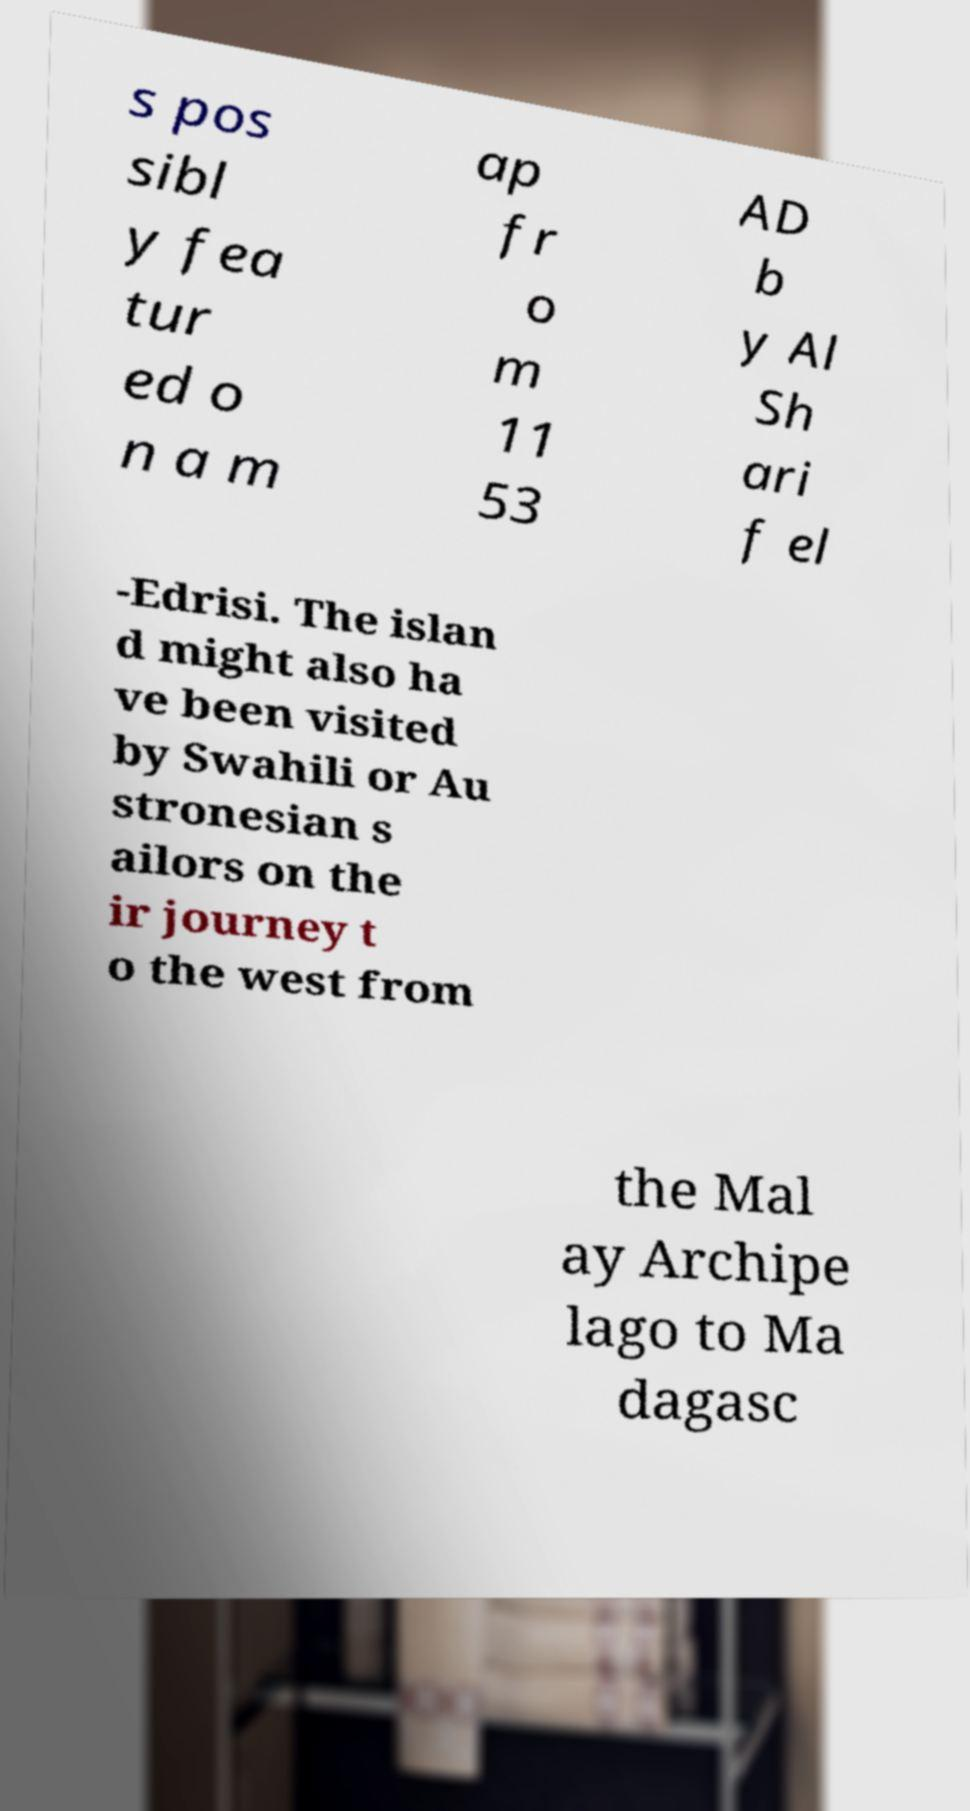Could you extract and type out the text from this image? s pos sibl y fea tur ed o n a m ap fr o m 11 53 AD b y Al Sh ari f el -Edrisi. The islan d might also ha ve been visited by Swahili or Au stronesian s ailors on the ir journey t o the west from the Mal ay Archipe lago to Ma dagasc 